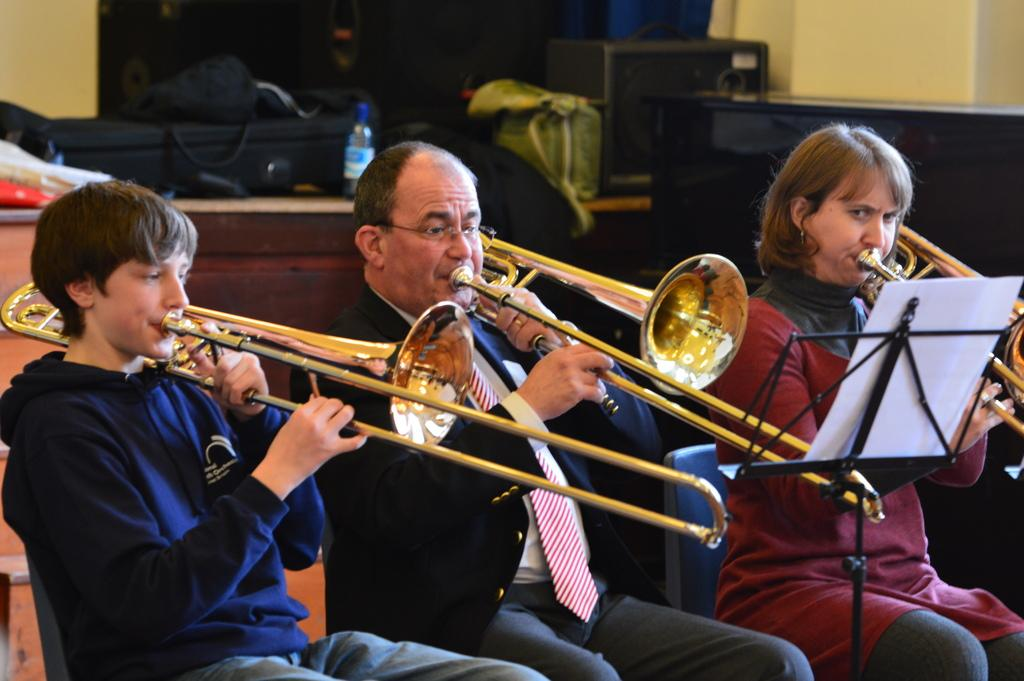What are the persons in the image doing? The persons in the image are blowing trombones. What objects can be seen in the image besides the trombones? There are bags, cupboards, a table, and a paper visible in the image. What type of prison can be seen in the image? There is no prison present in the image. What does the paper smell like in the image? The image does not provide any information about the smell of the paper. 